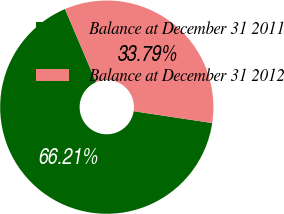<chart> <loc_0><loc_0><loc_500><loc_500><pie_chart><fcel>Balance at December 31 2011<fcel>Balance at December 31 2012<nl><fcel>66.21%<fcel>33.79%<nl></chart> 